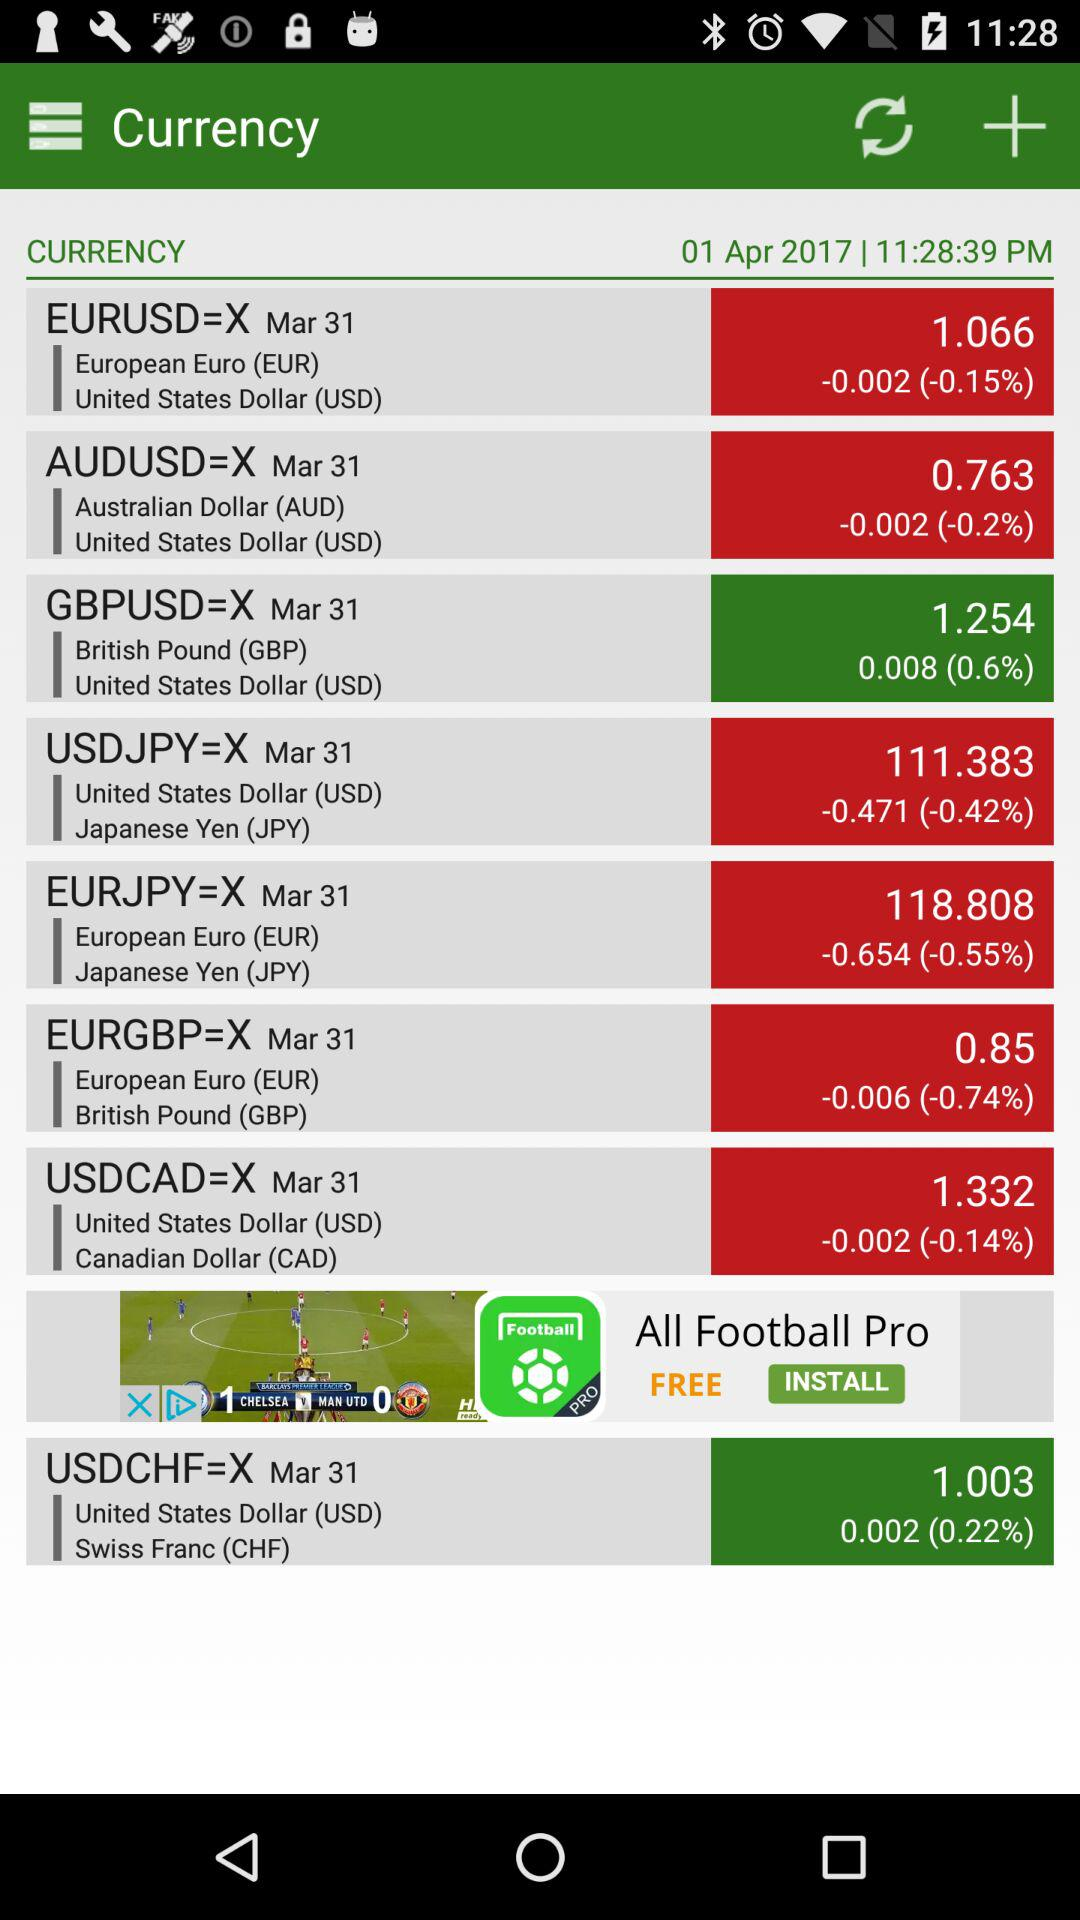What is the exchange rate between the European Euro and the US dollar? The exchange rate is 1.066. 